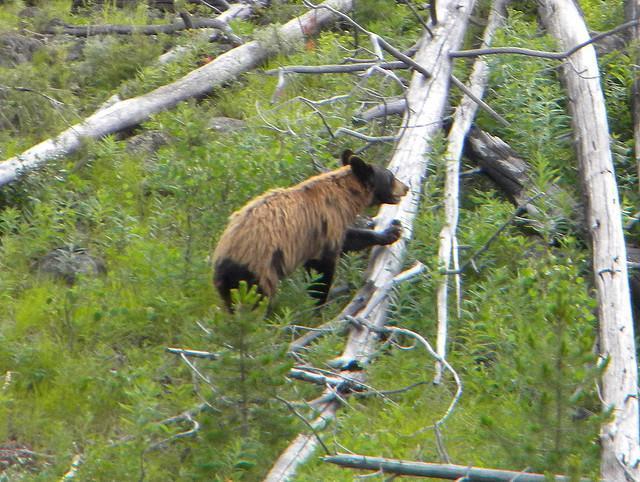How many people are in the photo?
Give a very brief answer. 0. 